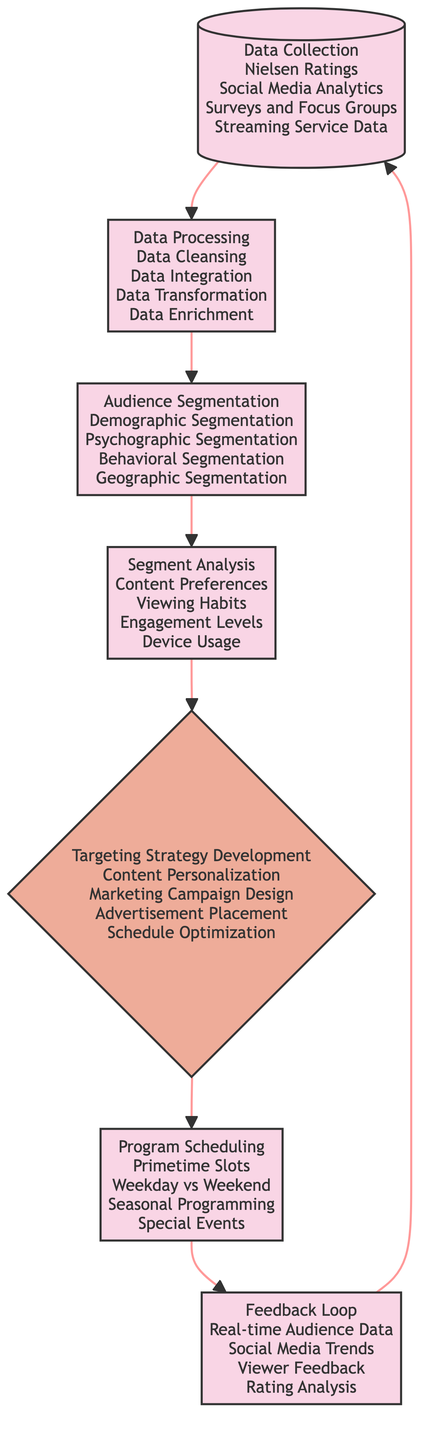What is the first step in the flowchart? The first step is labeled "Data Collection," which is the starting process noted at the top of the diagram.
Answer: Data Collection How many processes are there in total? By counting each labeled process in the flowchart, including Data Collection, Data Processing, Audience Segmentation, Segment Analysis, Program Scheduling, and Feedback Loop, we find there are six.
Answer: Six What does the decision node represent in the flowchart? The decision node labeled "Targeting Strategy Development" represents a critical step where strategies are formulated based on previous analyses before moving to program scheduling.
Answer: Targeting Strategy Development Which step follows Audience Segmentation? The flowchart connects Audience Segmentation directly to Segment Analysis, indicating that after audiences are segmented, the next step is to analyze these segments for deeper understanding.
Answer: Segment Analysis What kind of data sources are included in the Data Collection step? The Data Collection process includes sources such as Nielsen Ratings, Social Media Analytics, Surveys and Focus Groups, and Streaming Service Data, which are listed in the diagram.
Answer: Nielsen Ratings, Social Media Analytics, Surveys and Focus Groups, Streaming Service Data What process is linked to the Feedback Loop? The flowchart demonstrates a cyclical relationship, where the Feedback Loop leads back to Data Collection, indicating the importance of incorporating feedback into the ongoing data gathering process.
Answer: Data Collection How does the flowchart indicate program scheduling is influenced? Program Scheduling is based on the preceding Segment Analysis and Targeting Strategy Development, demonstrating that the scheduling of programs relies heavily on previously analyzed audience data and targeting strategies.
Answer: Segment Analysis and Targeting Strategy Development What type of segmentation is NOT mentioned in the Audience Segmentation step? The segmentation forms included are Demographic, Psychographic, Behavioral, and Geographic Segmentation; therefore, any other forms of segmentation, such as Technological, are not mentioned.
Answer: Technological Segmentation What aspect does the Segment Analysis focus on? Segment Analysis investigates aspects including Content Preferences, Viewing Habits, Engagement Levels, and Device Usage, which help in understanding each segment more comprehensively.
Answer: Content Preferences, Viewing Habits, Engagement Levels, Device Usage 